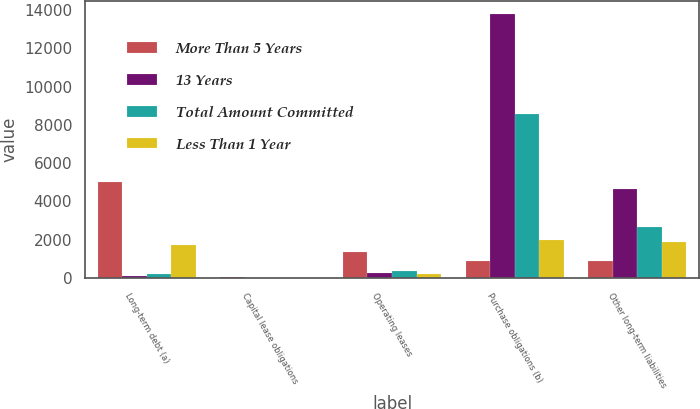<chart> <loc_0><loc_0><loc_500><loc_500><stacked_bar_chart><ecel><fcel>Long-term debt (a)<fcel>Capital lease obligations<fcel>Operating leases<fcel>Purchase obligations (b)<fcel>Other long-term liabilities<nl><fcel>More Than 5 Years<fcel>5029<fcel>27<fcel>1359<fcel>861<fcel>861<nl><fcel>13 Years<fcel>112<fcel>2<fcel>258<fcel>13806<fcel>4632<nl><fcel>Total Amount Committed<fcel>215<fcel>4<fcel>363<fcel>8594<fcel>2677<nl><fcel>Less Than 1 Year<fcel>1696<fcel>4<fcel>212<fcel>1983<fcel>1864<nl></chart> 